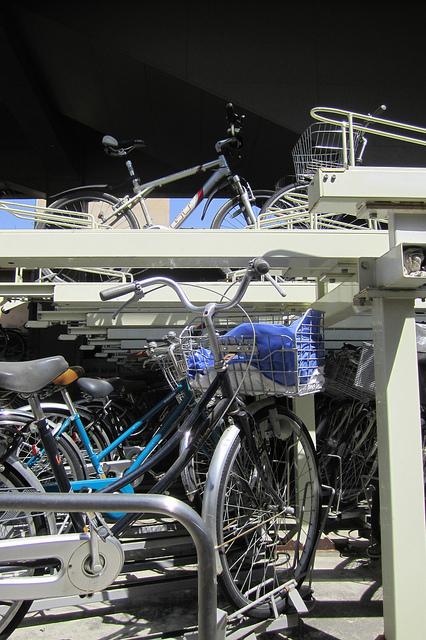Is this a bike storage?
Give a very brief answer. Yes. What is on the front of the bike?
Answer briefly. Basket. Do you see a red bicycle?
Be succinct. No. 